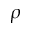Convert formula to latex. <formula><loc_0><loc_0><loc_500><loc_500>\rho</formula> 